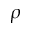Convert formula to latex. <formula><loc_0><loc_0><loc_500><loc_500>\rho</formula> 